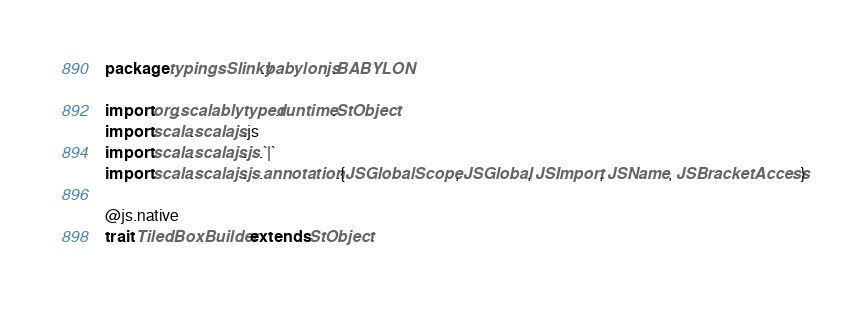Convert code to text. <code><loc_0><loc_0><loc_500><loc_500><_Scala_>package typingsSlinky.babylonjs.BABYLON

import org.scalablytyped.runtime.StObject
import scala.scalajs.js
import scala.scalajs.js.`|`
import scala.scalajs.js.annotation.{JSGlobalScope, JSGlobal, JSImport, JSName, JSBracketAccess}

@js.native
trait TiledBoxBuilder extends StObject
</code> 